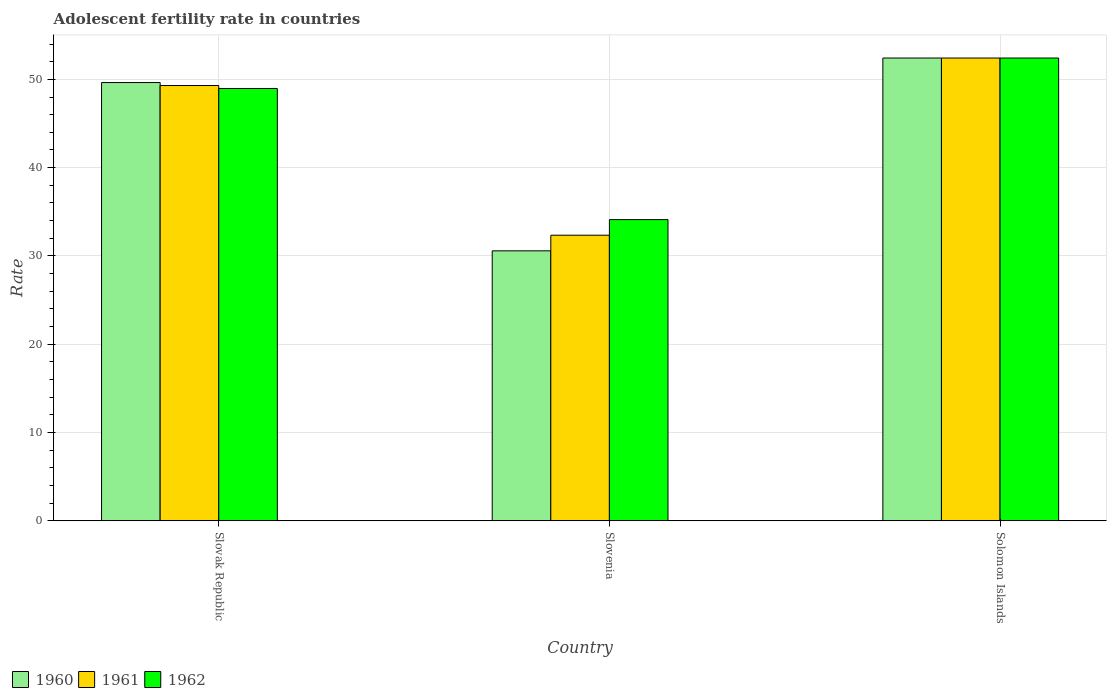How many groups of bars are there?
Provide a succinct answer. 3. Are the number of bars per tick equal to the number of legend labels?
Offer a very short reply. Yes. Are the number of bars on each tick of the X-axis equal?
Make the answer very short. Yes. How many bars are there on the 1st tick from the left?
Offer a very short reply. 3. How many bars are there on the 1st tick from the right?
Keep it short and to the point. 3. What is the label of the 1st group of bars from the left?
Offer a very short reply. Slovak Republic. What is the adolescent fertility rate in 1960 in Slovenia?
Keep it short and to the point. 30.58. Across all countries, what is the maximum adolescent fertility rate in 1960?
Provide a succinct answer. 52.42. Across all countries, what is the minimum adolescent fertility rate in 1961?
Provide a succinct answer. 32.35. In which country was the adolescent fertility rate in 1960 maximum?
Your response must be concise. Solomon Islands. In which country was the adolescent fertility rate in 1962 minimum?
Ensure brevity in your answer.  Slovenia. What is the total adolescent fertility rate in 1961 in the graph?
Offer a very short reply. 134.06. What is the difference between the adolescent fertility rate in 1962 in Slovak Republic and that in Solomon Islands?
Provide a succinct answer. -3.45. What is the difference between the adolescent fertility rate in 1960 in Solomon Islands and the adolescent fertility rate in 1961 in Slovenia?
Give a very brief answer. 20.07. What is the average adolescent fertility rate in 1960 per country?
Your answer should be very brief. 44.21. In how many countries, is the adolescent fertility rate in 1962 greater than 8?
Give a very brief answer. 3. What is the ratio of the adolescent fertility rate in 1961 in Slovak Republic to that in Solomon Islands?
Give a very brief answer. 0.94. Is the difference between the adolescent fertility rate in 1960 in Slovenia and Solomon Islands greater than the difference between the adolescent fertility rate in 1961 in Slovenia and Solomon Islands?
Give a very brief answer. No. What is the difference between the highest and the second highest adolescent fertility rate in 1961?
Provide a short and direct response. -16.95. What is the difference between the highest and the lowest adolescent fertility rate in 1961?
Provide a succinct answer. 20.07. In how many countries, is the adolescent fertility rate in 1962 greater than the average adolescent fertility rate in 1962 taken over all countries?
Ensure brevity in your answer.  2. Is the sum of the adolescent fertility rate in 1961 in Slovak Republic and Slovenia greater than the maximum adolescent fertility rate in 1960 across all countries?
Ensure brevity in your answer.  Yes. What does the 1st bar from the left in Solomon Islands represents?
Give a very brief answer. 1960. Are all the bars in the graph horizontal?
Give a very brief answer. No. Are the values on the major ticks of Y-axis written in scientific E-notation?
Provide a succinct answer. No. Does the graph contain any zero values?
Offer a terse response. No. Does the graph contain grids?
Keep it short and to the point. Yes. Where does the legend appear in the graph?
Keep it short and to the point. Bottom left. How many legend labels are there?
Provide a short and direct response. 3. How are the legend labels stacked?
Offer a very short reply. Horizontal. What is the title of the graph?
Make the answer very short. Adolescent fertility rate in countries. Does "2014" appear as one of the legend labels in the graph?
Offer a very short reply. No. What is the label or title of the Y-axis?
Offer a terse response. Rate. What is the Rate in 1960 in Slovak Republic?
Provide a succinct answer. 49.64. What is the Rate in 1961 in Slovak Republic?
Your answer should be compact. 49.3. What is the Rate in 1962 in Slovak Republic?
Make the answer very short. 48.96. What is the Rate in 1960 in Slovenia?
Offer a very short reply. 30.58. What is the Rate of 1961 in Slovenia?
Give a very brief answer. 32.35. What is the Rate of 1962 in Slovenia?
Make the answer very short. 34.12. What is the Rate in 1960 in Solomon Islands?
Your answer should be very brief. 52.42. What is the Rate in 1961 in Solomon Islands?
Your answer should be compact. 52.42. What is the Rate in 1962 in Solomon Islands?
Offer a very short reply. 52.42. Across all countries, what is the maximum Rate in 1960?
Offer a very short reply. 52.42. Across all countries, what is the maximum Rate of 1961?
Offer a very short reply. 52.42. Across all countries, what is the maximum Rate in 1962?
Ensure brevity in your answer.  52.42. Across all countries, what is the minimum Rate in 1960?
Make the answer very short. 30.58. Across all countries, what is the minimum Rate of 1961?
Offer a terse response. 32.35. Across all countries, what is the minimum Rate of 1962?
Give a very brief answer. 34.12. What is the total Rate in 1960 in the graph?
Offer a terse response. 132.63. What is the total Rate of 1961 in the graph?
Provide a succinct answer. 134.06. What is the total Rate of 1962 in the graph?
Make the answer very short. 135.5. What is the difference between the Rate in 1960 in Slovak Republic and that in Slovenia?
Provide a succinct answer. 19.06. What is the difference between the Rate in 1961 in Slovak Republic and that in Slovenia?
Provide a succinct answer. 16.95. What is the difference between the Rate of 1962 in Slovak Republic and that in Slovenia?
Keep it short and to the point. 14.85. What is the difference between the Rate in 1960 in Slovak Republic and that in Solomon Islands?
Offer a terse response. -2.78. What is the difference between the Rate of 1961 in Slovak Republic and that in Solomon Islands?
Provide a short and direct response. -3.12. What is the difference between the Rate of 1962 in Slovak Republic and that in Solomon Islands?
Offer a terse response. -3.45. What is the difference between the Rate in 1960 in Slovenia and that in Solomon Islands?
Ensure brevity in your answer.  -21.84. What is the difference between the Rate in 1961 in Slovenia and that in Solomon Islands?
Keep it short and to the point. -20.07. What is the difference between the Rate of 1962 in Slovenia and that in Solomon Islands?
Offer a terse response. -18.3. What is the difference between the Rate of 1960 in Slovak Republic and the Rate of 1961 in Slovenia?
Your answer should be very brief. 17.29. What is the difference between the Rate of 1960 in Slovak Republic and the Rate of 1962 in Slovenia?
Your response must be concise. 15.52. What is the difference between the Rate in 1961 in Slovak Republic and the Rate in 1962 in Slovenia?
Offer a terse response. 15.18. What is the difference between the Rate of 1960 in Slovak Republic and the Rate of 1961 in Solomon Islands?
Offer a terse response. -2.78. What is the difference between the Rate in 1960 in Slovak Republic and the Rate in 1962 in Solomon Islands?
Your response must be concise. -2.78. What is the difference between the Rate in 1961 in Slovak Republic and the Rate in 1962 in Solomon Islands?
Ensure brevity in your answer.  -3.12. What is the difference between the Rate in 1960 in Slovenia and the Rate in 1961 in Solomon Islands?
Keep it short and to the point. -21.84. What is the difference between the Rate of 1960 in Slovenia and the Rate of 1962 in Solomon Islands?
Keep it short and to the point. -21.84. What is the difference between the Rate in 1961 in Slovenia and the Rate in 1962 in Solomon Islands?
Provide a short and direct response. -20.07. What is the average Rate in 1960 per country?
Your answer should be compact. 44.21. What is the average Rate in 1961 per country?
Make the answer very short. 44.69. What is the average Rate of 1962 per country?
Offer a terse response. 45.16. What is the difference between the Rate in 1960 and Rate in 1961 in Slovak Republic?
Your answer should be compact. 0.34. What is the difference between the Rate of 1960 and Rate of 1962 in Slovak Republic?
Your answer should be compact. 0.67. What is the difference between the Rate in 1961 and Rate in 1962 in Slovak Republic?
Offer a very short reply. 0.34. What is the difference between the Rate in 1960 and Rate in 1961 in Slovenia?
Provide a short and direct response. -1.77. What is the difference between the Rate of 1960 and Rate of 1962 in Slovenia?
Your answer should be compact. -3.54. What is the difference between the Rate of 1961 and Rate of 1962 in Slovenia?
Give a very brief answer. -1.77. What is the difference between the Rate in 1961 and Rate in 1962 in Solomon Islands?
Your answer should be compact. 0. What is the ratio of the Rate in 1960 in Slovak Republic to that in Slovenia?
Provide a short and direct response. 1.62. What is the ratio of the Rate in 1961 in Slovak Republic to that in Slovenia?
Keep it short and to the point. 1.52. What is the ratio of the Rate of 1962 in Slovak Republic to that in Slovenia?
Offer a very short reply. 1.44. What is the ratio of the Rate of 1960 in Slovak Republic to that in Solomon Islands?
Provide a short and direct response. 0.95. What is the ratio of the Rate of 1961 in Slovak Republic to that in Solomon Islands?
Offer a terse response. 0.94. What is the ratio of the Rate in 1962 in Slovak Republic to that in Solomon Islands?
Your answer should be very brief. 0.93. What is the ratio of the Rate of 1960 in Slovenia to that in Solomon Islands?
Offer a very short reply. 0.58. What is the ratio of the Rate in 1961 in Slovenia to that in Solomon Islands?
Your response must be concise. 0.62. What is the ratio of the Rate in 1962 in Slovenia to that in Solomon Islands?
Make the answer very short. 0.65. What is the difference between the highest and the second highest Rate in 1960?
Your answer should be very brief. 2.78. What is the difference between the highest and the second highest Rate of 1961?
Provide a succinct answer. 3.12. What is the difference between the highest and the second highest Rate of 1962?
Keep it short and to the point. 3.45. What is the difference between the highest and the lowest Rate in 1960?
Your answer should be compact. 21.84. What is the difference between the highest and the lowest Rate in 1961?
Your answer should be very brief. 20.07. 